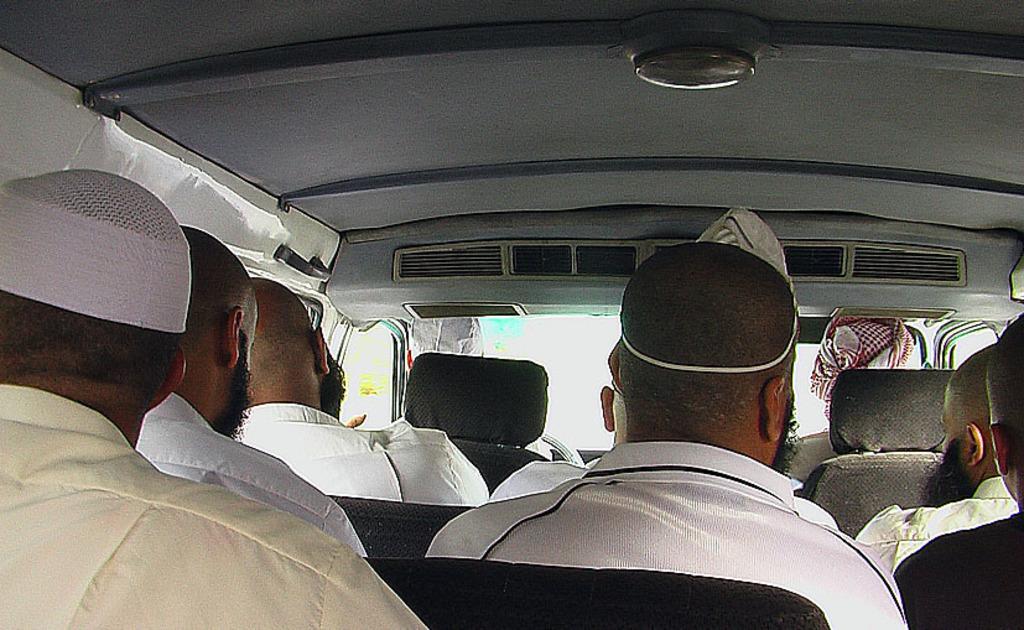Please provide a concise description of this image. This image is inside a car where few people are sitting by wearing white dress. 